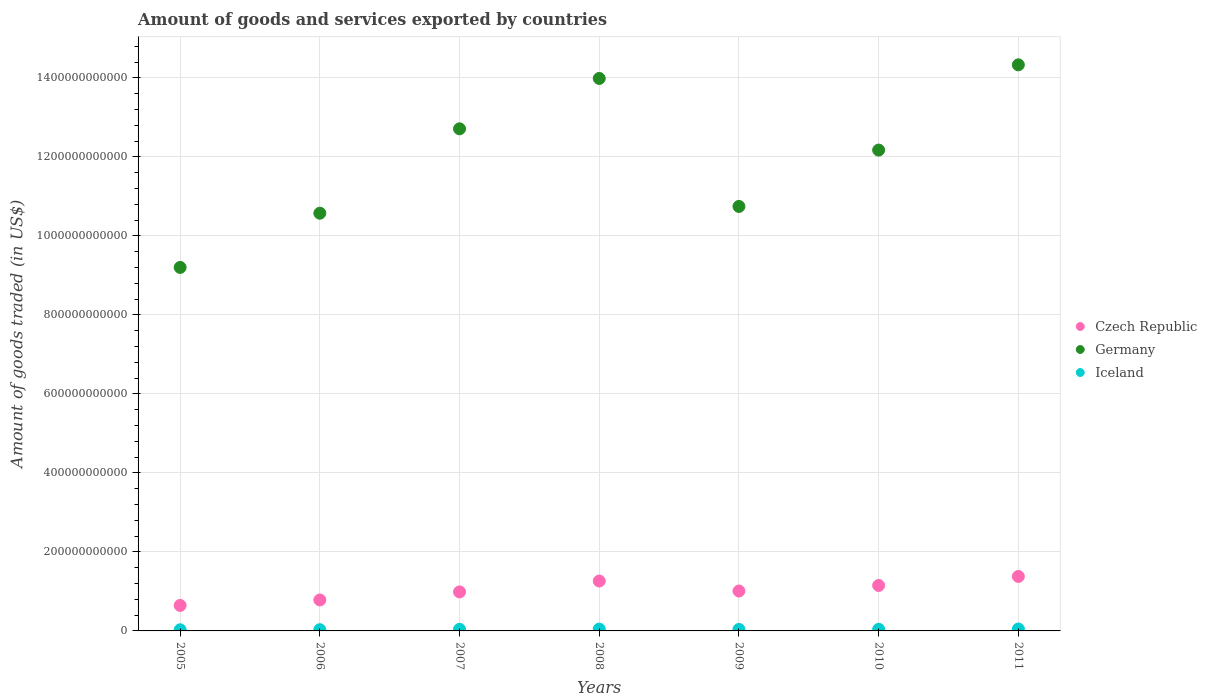What is the total amount of goods and services exported in Czech Republic in 2010?
Offer a terse response. 1.15e+11. Across all years, what is the maximum total amount of goods and services exported in Czech Republic?
Offer a very short reply. 1.38e+11. Across all years, what is the minimum total amount of goods and services exported in Germany?
Your answer should be compact. 9.20e+11. In which year was the total amount of goods and services exported in Germany maximum?
Your response must be concise. 2011. In which year was the total amount of goods and services exported in Iceland minimum?
Give a very brief answer. 2005. What is the total total amount of goods and services exported in Iceland in the graph?
Make the answer very short. 2.74e+1. What is the difference between the total amount of goods and services exported in Iceland in 2010 and that in 2011?
Offer a very short reply. -7.30e+08. What is the difference between the total amount of goods and services exported in Germany in 2006 and the total amount of goods and services exported in Czech Republic in 2008?
Your response must be concise. 9.31e+11. What is the average total amount of goods and services exported in Czech Republic per year?
Provide a short and direct response. 1.03e+11. In the year 2010, what is the difference between the total amount of goods and services exported in Germany and total amount of goods and services exported in Czech Republic?
Make the answer very short. 1.10e+12. In how many years, is the total amount of goods and services exported in Czech Republic greater than 360000000000 US$?
Your answer should be compact. 0. What is the ratio of the total amount of goods and services exported in Germany in 2006 to that in 2008?
Your response must be concise. 0.76. Is the difference between the total amount of goods and services exported in Germany in 2005 and 2008 greater than the difference between the total amount of goods and services exported in Czech Republic in 2005 and 2008?
Offer a terse response. No. What is the difference between the highest and the second highest total amount of goods and services exported in Iceland?
Offer a terse response. 1.99e+08. What is the difference between the highest and the lowest total amount of goods and services exported in Germany?
Provide a succinct answer. 5.13e+11. In how many years, is the total amount of goods and services exported in Czech Republic greater than the average total amount of goods and services exported in Czech Republic taken over all years?
Your answer should be very brief. 3. Is the sum of the total amount of goods and services exported in Germany in 2005 and 2009 greater than the maximum total amount of goods and services exported in Iceland across all years?
Make the answer very short. Yes. Does the total amount of goods and services exported in Czech Republic monotonically increase over the years?
Offer a very short reply. No. Is the total amount of goods and services exported in Germany strictly less than the total amount of goods and services exported in Iceland over the years?
Your answer should be very brief. No. How many dotlines are there?
Make the answer very short. 3. What is the difference between two consecutive major ticks on the Y-axis?
Provide a short and direct response. 2.00e+11. Are the values on the major ticks of Y-axis written in scientific E-notation?
Offer a terse response. No. How many legend labels are there?
Provide a succinct answer. 3. What is the title of the graph?
Give a very brief answer. Amount of goods and services exported by countries. Does "Portugal" appear as one of the legend labels in the graph?
Give a very brief answer. No. What is the label or title of the Y-axis?
Your response must be concise. Amount of goods traded (in US$). What is the Amount of goods traded (in US$) of Czech Republic in 2005?
Keep it short and to the point. 6.45e+1. What is the Amount of goods traded (in US$) in Germany in 2005?
Make the answer very short. 9.20e+11. What is the Amount of goods traded (in US$) of Iceland in 2005?
Make the answer very short. 2.89e+09. What is the Amount of goods traded (in US$) in Czech Republic in 2006?
Your answer should be very brief. 7.84e+1. What is the Amount of goods traded (in US$) in Germany in 2006?
Your answer should be compact. 1.06e+12. What is the Amount of goods traded (in US$) in Iceland in 2006?
Make the answer very short. 3.10e+09. What is the Amount of goods traded (in US$) in Czech Republic in 2007?
Ensure brevity in your answer.  9.88e+1. What is the Amount of goods traded (in US$) of Germany in 2007?
Give a very brief answer. 1.27e+12. What is the Amount of goods traded (in US$) of Iceland in 2007?
Your answer should be compact. 4.12e+09. What is the Amount of goods traded (in US$) in Czech Republic in 2008?
Provide a short and direct response. 1.26e+11. What is the Amount of goods traded (in US$) in Germany in 2008?
Provide a succinct answer. 1.40e+12. What is the Amount of goods traded (in US$) in Iceland in 2008?
Provide a succinct answer. 4.65e+09. What is the Amount of goods traded (in US$) in Czech Republic in 2009?
Your response must be concise. 1.01e+11. What is the Amount of goods traded (in US$) of Germany in 2009?
Keep it short and to the point. 1.07e+12. What is the Amount of goods traded (in US$) in Iceland in 2009?
Offer a terse response. 3.72e+09. What is the Amount of goods traded (in US$) of Czech Republic in 2010?
Provide a succinct answer. 1.15e+11. What is the Amount of goods traded (in US$) in Germany in 2010?
Your answer should be very brief. 1.22e+12. What is the Amount of goods traded (in US$) of Iceland in 2010?
Keep it short and to the point. 4.12e+09. What is the Amount of goods traded (in US$) of Czech Republic in 2011?
Offer a very short reply. 1.38e+11. What is the Amount of goods traded (in US$) of Germany in 2011?
Your answer should be very brief. 1.43e+12. What is the Amount of goods traded (in US$) in Iceland in 2011?
Provide a short and direct response. 4.85e+09. Across all years, what is the maximum Amount of goods traded (in US$) in Czech Republic?
Offer a very short reply. 1.38e+11. Across all years, what is the maximum Amount of goods traded (in US$) in Germany?
Ensure brevity in your answer.  1.43e+12. Across all years, what is the maximum Amount of goods traded (in US$) in Iceland?
Give a very brief answer. 4.85e+09. Across all years, what is the minimum Amount of goods traded (in US$) in Czech Republic?
Ensure brevity in your answer.  6.45e+1. Across all years, what is the minimum Amount of goods traded (in US$) in Germany?
Keep it short and to the point. 9.20e+11. Across all years, what is the minimum Amount of goods traded (in US$) of Iceland?
Your answer should be compact. 2.89e+09. What is the total Amount of goods traded (in US$) of Czech Republic in the graph?
Offer a terse response. 7.22e+11. What is the total Amount of goods traded (in US$) of Germany in the graph?
Your answer should be compact. 8.37e+12. What is the total Amount of goods traded (in US$) in Iceland in the graph?
Ensure brevity in your answer.  2.74e+1. What is the difference between the Amount of goods traded (in US$) in Czech Republic in 2005 and that in 2006?
Give a very brief answer. -1.38e+1. What is the difference between the Amount of goods traded (in US$) in Germany in 2005 and that in 2006?
Your answer should be very brief. -1.37e+11. What is the difference between the Amount of goods traded (in US$) of Iceland in 2005 and that in 2006?
Keep it short and to the point. -2.13e+08. What is the difference between the Amount of goods traded (in US$) in Czech Republic in 2005 and that in 2007?
Your response must be concise. -3.43e+1. What is the difference between the Amount of goods traded (in US$) in Germany in 2005 and that in 2007?
Offer a very short reply. -3.51e+11. What is the difference between the Amount of goods traded (in US$) of Iceland in 2005 and that in 2007?
Provide a succinct answer. -1.23e+09. What is the difference between the Amount of goods traded (in US$) of Czech Republic in 2005 and that in 2008?
Ensure brevity in your answer.  -6.18e+1. What is the difference between the Amount of goods traded (in US$) in Germany in 2005 and that in 2008?
Make the answer very short. -4.78e+11. What is the difference between the Amount of goods traded (in US$) of Iceland in 2005 and that in 2008?
Offer a very short reply. -1.77e+09. What is the difference between the Amount of goods traded (in US$) in Czech Republic in 2005 and that in 2009?
Make the answer very short. -3.65e+1. What is the difference between the Amount of goods traded (in US$) in Germany in 2005 and that in 2009?
Offer a very short reply. -1.54e+11. What is the difference between the Amount of goods traded (in US$) of Iceland in 2005 and that in 2009?
Keep it short and to the point. -8.30e+08. What is the difference between the Amount of goods traded (in US$) of Czech Republic in 2005 and that in 2010?
Offer a terse response. -5.05e+1. What is the difference between the Amount of goods traded (in US$) of Germany in 2005 and that in 2010?
Provide a succinct answer. -2.97e+11. What is the difference between the Amount of goods traded (in US$) in Iceland in 2005 and that in 2010?
Offer a very short reply. -1.24e+09. What is the difference between the Amount of goods traded (in US$) in Czech Republic in 2005 and that in 2011?
Keep it short and to the point. -7.34e+1. What is the difference between the Amount of goods traded (in US$) in Germany in 2005 and that in 2011?
Your answer should be very brief. -5.13e+11. What is the difference between the Amount of goods traded (in US$) of Iceland in 2005 and that in 2011?
Give a very brief answer. -1.97e+09. What is the difference between the Amount of goods traded (in US$) in Czech Republic in 2006 and that in 2007?
Give a very brief answer. -2.04e+1. What is the difference between the Amount of goods traded (in US$) of Germany in 2006 and that in 2007?
Offer a very short reply. -2.14e+11. What is the difference between the Amount of goods traded (in US$) of Iceland in 2006 and that in 2007?
Make the answer very short. -1.02e+09. What is the difference between the Amount of goods traded (in US$) of Czech Republic in 2006 and that in 2008?
Make the answer very short. -4.80e+1. What is the difference between the Amount of goods traded (in US$) of Germany in 2006 and that in 2008?
Your answer should be very brief. -3.41e+11. What is the difference between the Amount of goods traded (in US$) in Iceland in 2006 and that in 2008?
Ensure brevity in your answer.  -1.55e+09. What is the difference between the Amount of goods traded (in US$) in Czech Republic in 2006 and that in 2009?
Keep it short and to the point. -2.26e+1. What is the difference between the Amount of goods traded (in US$) of Germany in 2006 and that in 2009?
Provide a short and direct response. -1.71e+1. What is the difference between the Amount of goods traded (in US$) of Iceland in 2006 and that in 2009?
Keep it short and to the point. -6.17e+08. What is the difference between the Amount of goods traded (in US$) of Czech Republic in 2006 and that in 2010?
Ensure brevity in your answer.  -3.67e+1. What is the difference between the Amount of goods traded (in US$) in Germany in 2006 and that in 2010?
Ensure brevity in your answer.  -1.60e+11. What is the difference between the Amount of goods traded (in US$) in Iceland in 2006 and that in 2010?
Your answer should be very brief. -1.02e+09. What is the difference between the Amount of goods traded (in US$) of Czech Republic in 2006 and that in 2011?
Offer a very short reply. -5.95e+1. What is the difference between the Amount of goods traded (in US$) of Germany in 2006 and that in 2011?
Offer a very short reply. -3.76e+11. What is the difference between the Amount of goods traded (in US$) in Iceland in 2006 and that in 2011?
Ensure brevity in your answer.  -1.75e+09. What is the difference between the Amount of goods traded (in US$) in Czech Republic in 2007 and that in 2008?
Your answer should be very brief. -2.76e+1. What is the difference between the Amount of goods traded (in US$) in Germany in 2007 and that in 2008?
Offer a terse response. -1.27e+11. What is the difference between the Amount of goods traded (in US$) of Iceland in 2007 and that in 2008?
Ensure brevity in your answer.  -5.34e+08. What is the difference between the Amount of goods traded (in US$) in Czech Republic in 2007 and that in 2009?
Ensure brevity in your answer.  -2.24e+09. What is the difference between the Amount of goods traded (in US$) in Germany in 2007 and that in 2009?
Keep it short and to the point. 1.96e+11. What is the difference between the Amount of goods traded (in US$) of Iceland in 2007 and that in 2009?
Your answer should be very brief. 4.02e+08. What is the difference between the Amount of goods traded (in US$) in Czech Republic in 2007 and that in 2010?
Ensure brevity in your answer.  -1.63e+1. What is the difference between the Amount of goods traded (in US$) of Germany in 2007 and that in 2010?
Make the answer very short. 5.38e+1. What is the difference between the Amount of goods traded (in US$) in Iceland in 2007 and that in 2010?
Your response must be concise. -3.23e+06. What is the difference between the Amount of goods traded (in US$) of Czech Republic in 2007 and that in 2011?
Keep it short and to the point. -3.91e+1. What is the difference between the Amount of goods traded (in US$) in Germany in 2007 and that in 2011?
Your answer should be compact. -1.62e+11. What is the difference between the Amount of goods traded (in US$) of Iceland in 2007 and that in 2011?
Make the answer very short. -7.33e+08. What is the difference between the Amount of goods traded (in US$) of Czech Republic in 2008 and that in 2009?
Make the answer very short. 2.53e+1. What is the difference between the Amount of goods traded (in US$) in Germany in 2008 and that in 2009?
Your answer should be very brief. 3.24e+11. What is the difference between the Amount of goods traded (in US$) of Iceland in 2008 and that in 2009?
Make the answer very short. 9.37e+08. What is the difference between the Amount of goods traded (in US$) of Czech Republic in 2008 and that in 2010?
Provide a succinct answer. 1.13e+1. What is the difference between the Amount of goods traded (in US$) in Germany in 2008 and that in 2010?
Your response must be concise. 1.81e+11. What is the difference between the Amount of goods traded (in US$) of Iceland in 2008 and that in 2010?
Make the answer very short. 5.31e+08. What is the difference between the Amount of goods traded (in US$) of Czech Republic in 2008 and that in 2011?
Give a very brief answer. -1.15e+1. What is the difference between the Amount of goods traded (in US$) of Germany in 2008 and that in 2011?
Offer a very short reply. -3.45e+1. What is the difference between the Amount of goods traded (in US$) of Iceland in 2008 and that in 2011?
Provide a short and direct response. -1.99e+08. What is the difference between the Amount of goods traded (in US$) in Czech Republic in 2009 and that in 2010?
Offer a very short reply. -1.40e+1. What is the difference between the Amount of goods traded (in US$) in Germany in 2009 and that in 2010?
Provide a short and direct response. -1.43e+11. What is the difference between the Amount of goods traded (in US$) of Iceland in 2009 and that in 2010?
Keep it short and to the point. -4.06e+08. What is the difference between the Amount of goods traded (in US$) of Czech Republic in 2009 and that in 2011?
Make the answer very short. -3.69e+1. What is the difference between the Amount of goods traded (in US$) in Germany in 2009 and that in 2011?
Your response must be concise. -3.58e+11. What is the difference between the Amount of goods traded (in US$) in Iceland in 2009 and that in 2011?
Your answer should be compact. -1.14e+09. What is the difference between the Amount of goods traded (in US$) of Czech Republic in 2010 and that in 2011?
Give a very brief answer. -2.28e+1. What is the difference between the Amount of goods traded (in US$) of Germany in 2010 and that in 2011?
Provide a succinct answer. -2.16e+11. What is the difference between the Amount of goods traded (in US$) in Iceland in 2010 and that in 2011?
Your answer should be compact. -7.30e+08. What is the difference between the Amount of goods traded (in US$) in Czech Republic in 2005 and the Amount of goods traded (in US$) in Germany in 2006?
Give a very brief answer. -9.93e+11. What is the difference between the Amount of goods traded (in US$) of Czech Republic in 2005 and the Amount of goods traded (in US$) of Iceland in 2006?
Give a very brief answer. 6.14e+1. What is the difference between the Amount of goods traded (in US$) of Germany in 2005 and the Amount of goods traded (in US$) of Iceland in 2006?
Offer a very short reply. 9.17e+11. What is the difference between the Amount of goods traded (in US$) of Czech Republic in 2005 and the Amount of goods traded (in US$) of Germany in 2007?
Make the answer very short. -1.21e+12. What is the difference between the Amount of goods traded (in US$) in Czech Republic in 2005 and the Amount of goods traded (in US$) in Iceland in 2007?
Your answer should be compact. 6.04e+1. What is the difference between the Amount of goods traded (in US$) of Germany in 2005 and the Amount of goods traded (in US$) of Iceland in 2007?
Ensure brevity in your answer.  9.16e+11. What is the difference between the Amount of goods traded (in US$) in Czech Republic in 2005 and the Amount of goods traded (in US$) in Germany in 2008?
Your answer should be very brief. -1.33e+12. What is the difference between the Amount of goods traded (in US$) in Czech Republic in 2005 and the Amount of goods traded (in US$) in Iceland in 2008?
Your answer should be very brief. 5.99e+1. What is the difference between the Amount of goods traded (in US$) of Germany in 2005 and the Amount of goods traded (in US$) of Iceland in 2008?
Your answer should be very brief. 9.15e+11. What is the difference between the Amount of goods traded (in US$) of Czech Republic in 2005 and the Amount of goods traded (in US$) of Germany in 2009?
Your response must be concise. -1.01e+12. What is the difference between the Amount of goods traded (in US$) in Czech Republic in 2005 and the Amount of goods traded (in US$) in Iceland in 2009?
Ensure brevity in your answer.  6.08e+1. What is the difference between the Amount of goods traded (in US$) of Germany in 2005 and the Amount of goods traded (in US$) of Iceland in 2009?
Give a very brief answer. 9.16e+11. What is the difference between the Amount of goods traded (in US$) in Czech Republic in 2005 and the Amount of goods traded (in US$) in Germany in 2010?
Offer a terse response. -1.15e+12. What is the difference between the Amount of goods traded (in US$) in Czech Republic in 2005 and the Amount of goods traded (in US$) in Iceland in 2010?
Offer a terse response. 6.04e+1. What is the difference between the Amount of goods traded (in US$) in Germany in 2005 and the Amount of goods traded (in US$) in Iceland in 2010?
Offer a terse response. 9.16e+11. What is the difference between the Amount of goods traded (in US$) of Czech Republic in 2005 and the Amount of goods traded (in US$) of Germany in 2011?
Make the answer very short. -1.37e+12. What is the difference between the Amount of goods traded (in US$) of Czech Republic in 2005 and the Amount of goods traded (in US$) of Iceland in 2011?
Offer a very short reply. 5.97e+1. What is the difference between the Amount of goods traded (in US$) in Germany in 2005 and the Amount of goods traded (in US$) in Iceland in 2011?
Make the answer very short. 9.15e+11. What is the difference between the Amount of goods traded (in US$) in Czech Republic in 2006 and the Amount of goods traded (in US$) in Germany in 2007?
Ensure brevity in your answer.  -1.19e+12. What is the difference between the Amount of goods traded (in US$) of Czech Republic in 2006 and the Amount of goods traded (in US$) of Iceland in 2007?
Offer a very short reply. 7.43e+1. What is the difference between the Amount of goods traded (in US$) in Germany in 2006 and the Amount of goods traded (in US$) in Iceland in 2007?
Offer a terse response. 1.05e+12. What is the difference between the Amount of goods traded (in US$) in Czech Republic in 2006 and the Amount of goods traded (in US$) in Germany in 2008?
Give a very brief answer. -1.32e+12. What is the difference between the Amount of goods traded (in US$) of Czech Republic in 2006 and the Amount of goods traded (in US$) of Iceland in 2008?
Make the answer very short. 7.37e+1. What is the difference between the Amount of goods traded (in US$) in Germany in 2006 and the Amount of goods traded (in US$) in Iceland in 2008?
Offer a very short reply. 1.05e+12. What is the difference between the Amount of goods traded (in US$) in Czech Republic in 2006 and the Amount of goods traded (in US$) in Germany in 2009?
Provide a succinct answer. -9.96e+11. What is the difference between the Amount of goods traded (in US$) in Czech Republic in 2006 and the Amount of goods traded (in US$) in Iceland in 2009?
Ensure brevity in your answer.  7.47e+1. What is the difference between the Amount of goods traded (in US$) of Germany in 2006 and the Amount of goods traded (in US$) of Iceland in 2009?
Ensure brevity in your answer.  1.05e+12. What is the difference between the Amount of goods traded (in US$) in Czech Republic in 2006 and the Amount of goods traded (in US$) in Germany in 2010?
Your answer should be very brief. -1.14e+12. What is the difference between the Amount of goods traded (in US$) of Czech Republic in 2006 and the Amount of goods traded (in US$) of Iceland in 2010?
Your response must be concise. 7.43e+1. What is the difference between the Amount of goods traded (in US$) of Germany in 2006 and the Amount of goods traded (in US$) of Iceland in 2010?
Offer a very short reply. 1.05e+12. What is the difference between the Amount of goods traded (in US$) of Czech Republic in 2006 and the Amount of goods traded (in US$) of Germany in 2011?
Offer a very short reply. -1.35e+12. What is the difference between the Amount of goods traded (in US$) of Czech Republic in 2006 and the Amount of goods traded (in US$) of Iceland in 2011?
Give a very brief answer. 7.35e+1. What is the difference between the Amount of goods traded (in US$) in Germany in 2006 and the Amount of goods traded (in US$) in Iceland in 2011?
Keep it short and to the point. 1.05e+12. What is the difference between the Amount of goods traded (in US$) of Czech Republic in 2007 and the Amount of goods traded (in US$) of Germany in 2008?
Make the answer very short. -1.30e+12. What is the difference between the Amount of goods traded (in US$) of Czech Republic in 2007 and the Amount of goods traded (in US$) of Iceland in 2008?
Your response must be concise. 9.41e+1. What is the difference between the Amount of goods traded (in US$) of Germany in 2007 and the Amount of goods traded (in US$) of Iceland in 2008?
Offer a terse response. 1.27e+12. What is the difference between the Amount of goods traded (in US$) in Czech Republic in 2007 and the Amount of goods traded (in US$) in Germany in 2009?
Offer a terse response. -9.76e+11. What is the difference between the Amount of goods traded (in US$) of Czech Republic in 2007 and the Amount of goods traded (in US$) of Iceland in 2009?
Your answer should be very brief. 9.51e+1. What is the difference between the Amount of goods traded (in US$) of Germany in 2007 and the Amount of goods traded (in US$) of Iceland in 2009?
Your response must be concise. 1.27e+12. What is the difference between the Amount of goods traded (in US$) in Czech Republic in 2007 and the Amount of goods traded (in US$) in Germany in 2010?
Your answer should be very brief. -1.12e+12. What is the difference between the Amount of goods traded (in US$) of Czech Republic in 2007 and the Amount of goods traded (in US$) of Iceland in 2010?
Make the answer very short. 9.47e+1. What is the difference between the Amount of goods traded (in US$) in Germany in 2007 and the Amount of goods traded (in US$) in Iceland in 2010?
Your answer should be very brief. 1.27e+12. What is the difference between the Amount of goods traded (in US$) in Czech Republic in 2007 and the Amount of goods traded (in US$) in Germany in 2011?
Keep it short and to the point. -1.33e+12. What is the difference between the Amount of goods traded (in US$) of Czech Republic in 2007 and the Amount of goods traded (in US$) of Iceland in 2011?
Provide a succinct answer. 9.39e+1. What is the difference between the Amount of goods traded (in US$) of Germany in 2007 and the Amount of goods traded (in US$) of Iceland in 2011?
Your answer should be very brief. 1.27e+12. What is the difference between the Amount of goods traded (in US$) in Czech Republic in 2008 and the Amount of goods traded (in US$) in Germany in 2009?
Offer a very short reply. -9.48e+11. What is the difference between the Amount of goods traded (in US$) in Czech Republic in 2008 and the Amount of goods traded (in US$) in Iceland in 2009?
Keep it short and to the point. 1.23e+11. What is the difference between the Amount of goods traded (in US$) of Germany in 2008 and the Amount of goods traded (in US$) of Iceland in 2009?
Keep it short and to the point. 1.39e+12. What is the difference between the Amount of goods traded (in US$) in Czech Republic in 2008 and the Amount of goods traded (in US$) in Germany in 2010?
Your answer should be very brief. -1.09e+12. What is the difference between the Amount of goods traded (in US$) in Czech Republic in 2008 and the Amount of goods traded (in US$) in Iceland in 2010?
Keep it short and to the point. 1.22e+11. What is the difference between the Amount of goods traded (in US$) of Germany in 2008 and the Amount of goods traded (in US$) of Iceland in 2010?
Your response must be concise. 1.39e+12. What is the difference between the Amount of goods traded (in US$) of Czech Republic in 2008 and the Amount of goods traded (in US$) of Germany in 2011?
Offer a very short reply. -1.31e+12. What is the difference between the Amount of goods traded (in US$) of Czech Republic in 2008 and the Amount of goods traded (in US$) of Iceland in 2011?
Offer a very short reply. 1.21e+11. What is the difference between the Amount of goods traded (in US$) in Germany in 2008 and the Amount of goods traded (in US$) in Iceland in 2011?
Your response must be concise. 1.39e+12. What is the difference between the Amount of goods traded (in US$) in Czech Republic in 2009 and the Amount of goods traded (in US$) in Germany in 2010?
Your response must be concise. -1.12e+12. What is the difference between the Amount of goods traded (in US$) in Czech Republic in 2009 and the Amount of goods traded (in US$) in Iceland in 2010?
Ensure brevity in your answer.  9.69e+1. What is the difference between the Amount of goods traded (in US$) in Germany in 2009 and the Amount of goods traded (in US$) in Iceland in 2010?
Your answer should be compact. 1.07e+12. What is the difference between the Amount of goods traded (in US$) of Czech Republic in 2009 and the Amount of goods traded (in US$) of Germany in 2011?
Offer a terse response. -1.33e+12. What is the difference between the Amount of goods traded (in US$) in Czech Republic in 2009 and the Amount of goods traded (in US$) in Iceland in 2011?
Ensure brevity in your answer.  9.62e+1. What is the difference between the Amount of goods traded (in US$) of Germany in 2009 and the Amount of goods traded (in US$) of Iceland in 2011?
Provide a short and direct response. 1.07e+12. What is the difference between the Amount of goods traded (in US$) in Czech Republic in 2010 and the Amount of goods traded (in US$) in Germany in 2011?
Give a very brief answer. -1.32e+12. What is the difference between the Amount of goods traded (in US$) in Czech Republic in 2010 and the Amount of goods traded (in US$) in Iceland in 2011?
Give a very brief answer. 1.10e+11. What is the difference between the Amount of goods traded (in US$) of Germany in 2010 and the Amount of goods traded (in US$) of Iceland in 2011?
Ensure brevity in your answer.  1.21e+12. What is the average Amount of goods traded (in US$) in Czech Republic per year?
Your answer should be very brief. 1.03e+11. What is the average Amount of goods traded (in US$) of Germany per year?
Make the answer very short. 1.20e+12. What is the average Amount of goods traded (in US$) in Iceland per year?
Offer a terse response. 3.92e+09. In the year 2005, what is the difference between the Amount of goods traded (in US$) in Czech Republic and Amount of goods traded (in US$) in Germany?
Give a very brief answer. -8.56e+11. In the year 2005, what is the difference between the Amount of goods traded (in US$) of Czech Republic and Amount of goods traded (in US$) of Iceland?
Your answer should be very brief. 6.16e+1. In the year 2005, what is the difference between the Amount of goods traded (in US$) in Germany and Amount of goods traded (in US$) in Iceland?
Your response must be concise. 9.17e+11. In the year 2006, what is the difference between the Amount of goods traded (in US$) in Czech Republic and Amount of goods traded (in US$) in Germany?
Keep it short and to the point. -9.79e+11. In the year 2006, what is the difference between the Amount of goods traded (in US$) in Czech Republic and Amount of goods traded (in US$) in Iceland?
Make the answer very short. 7.53e+1. In the year 2006, what is the difference between the Amount of goods traded (in US$) in Germany and Amount of goods traded (in US$) in Iceland?
Offer a very short reply. 1.05e+12. In the year 2007, what is the difference between the Amount of goods traded (in US$) in Czech Republic and Amount of goods traded (in US$) in Germany?
Provide a succinct answer. -1.17e+12. In the year 2007, what is the difference between the Amount of goods traded (in US$) of Czech Republic and Amount of goods traded (in US$) of Iceland?
Offer a very short reply. 9.47e+1. In the year 2007, what is the difference between the Amount of goods traded (in US$) in Germany and Amount of goods traded (in US$) in Iceland?
Your answer should be very brief. 1.27e+12. In the year 2008, what is the difference between the Amount of goods traded (in US$) in Czech Republic and Amount of goods traded (in US$) in Germany?
Your answer should be very brief. -1.27e+12. In the year 2008, what is the difference between the Amount of goods traded (in US$) in Czech Republic and Amount of goods traded (in US$) in Iceland?
Your answer should be very brief. 1.22e+11. In the year 2008, what is the difference between the Amount of goods traded (in US$) in Germany and Amount of goods traded (in US$) in Iceland?
Give a very brief answer. 1.39e+12. In the year 2009, what is the difference between the Amount of goods traded (in US$) in Czech Republic and Amount of goods traded (in US$) in Germany?
Provide a succinct answer. -9.73e+11. In the year 2009, what is the difference between the Amount of goods traded (in US$) of Czech Republic and Amount of goods traded (in US$) of Iceland?
Keep it short and to the point. 9.73e+1. In the year 2009, what is the difference between the Amount of goods traded (in US$) of Germany and Amount of goods traded (in US$) of Iceland?
Provide a short and direct response. 1.07e+12. In the year 2010, what is the difference between the Amount of goods traded (in US$) in Czech Republic and Amount of goods traded (in US$) in Germany?
Provide a short and direct response. -1.10e+12. In the year 2010, what is the difference between the Amount of goods traded (in US$) of Czech Republic and Amount of goods traded (in US$) of Iceland?
Make the answer very short. 1.11e+11. In the year 2010, what is the difference between the Amount of goods traded (in US$) in Germany and Amount of goods traded (in US$) in Iceland?
Give a very brief answer. 1.21e+12. In the year 2011, what is the difference between the Amount of goods traded (in US$) of Czech Republic and Amount of goods traded (in US$) of Germany?
Keep it short and to the point. -1.30e+12. In the year 2011, what is the difference between the Amount of goods traded (in US$) in Czech Republic and Amount of goods traded (in US$) in Iceland?
Your response must be concise. 1.33e+11. In the year 2011, what is the difference between the Amount of goods traded (in US$) of Germany and Amount of goods traded (in US$) of Iceland?
Give a very brief answer. 1.43e+12. What is the ratio of the Amount of goods traded (in US$) of Czech Republic in 2005 to that in 2006?
Offer a terse response. 0.82. What is the ratio of the Amount of goods traded (in US$) of Germany in 2005 to that in 2006?
Offer a very short reply. 0.87. What is the ratio of the Amount of goods traded (in US$) in Iceland in 2005 to that in 2006?
Your response must be concise. 0.93. What is the ratio of the Amount of goods traded (in US$) of Czech Republic in 2005 to that in 2007?
Offer a very short reply. 0.65. What is the ratio of the Amount of goods traded (in US$) of Germany in 2005 to that in 2007?
Your response must be concise. 0.72. What is the ratio of the Amount of goods traded (in US$) in Iceland in 2005 to that in 2007?
Make the answer very short. 0.7. What is the ratio of the Amount of goods traded (in US$) of Czech Republic in 2005 to that in 2008?
Offer a terse response. 0.51. What is the ratio of the Amount of goods traded (in US$) in Germany in 2005 to that in 2008?
Provide a succinct answer. 0.66. What is the ratio of the Amount of goods traded (in US$) in Iceland in 2005 to that in 2008?
Your answer should be compact. 0.62. What is the ratio of the Amount of goods traded (in US$) in Czech Republic in 2005 to that in 2009?
Offer a terse response. 0.64. What is the ratio of the Amount of goods traded (in US$) of Germany in 2005 to that in 2009?
Provide a succinct answer. 0.86. What is the ratio of the Amount of goods traded (in US$) in Iceland in 2005 to that in 2009?
Provide a short and direct response. 0.78. What is the ratio of the Amount of goods traded (in US$) in Czech Republic in 2005 to that in 2010?
Your answer should be very brief. 0.56. What is the ratio of the Amount of goods traded (in US$) of Germany in 2005 to that in 2010?
Your response must be concise. 0.76. What is the ratio of the Amount of goods traded (in US$) of Iceland in 2005 to that in 2010?
Your response must be concise. 0.7. What is the ratio of the Amount of goods traded (in US$) in Czech Republic in 2005 to that in 2011?
Make the answer very short. 0.47. What is the ratio of the Amount of goods traded (in US$) in Germany in 2005 to that in 2011?
Make the answer very short. 0.64. What is the ratio of the Amount of goods traded (in US$) of Iceland in 2005 to that in 2011?
Your answer should be compact. 0.59. What is the ratio of the Amount of goods traded (in US$) of Czech Republic in 2006 to that in 2007?
Keep it short and to the point. 0.79. What is the ratio of the Amount of goods traded (in US$) in Germany in 2006 to that in 2007?
Provide a short and direct response. 0.83. What is the ratio of the Amount of goods traded (in US$) in Iceland in 2006 to that in 2007?
Give a very brief answer. 0.75. What is the ratio of the Amount of goods traded (in US$) in Czech Republic in 2006 to that in 2008?
Your response must be concise. 0.62. What is the ratio of the Amount of goods traded (in US$) in Germany in 2006 to that in 2008?
Your answer should be very brief. 0.76. What is the ratio of the Amount of goods traded (in US$) in Iceland in 2006 to that in 2008?
Give a very brief answer. 0.67. What is the ratio of the Amount of goods traded (in US$) in Czech Republic in 2006 to that in 2009?
Your answer should be compact. 0.78. What is the ratio of the Amount of goods traded (in US$) of Germany in 2006 to that in 2009?
Your answer should be compact. 0.98. What is the ratio of the Amount of goods traded (in US$) of Iceland in 2006 to that in 2009?
Your response must be concise. 0.83. What is the ratio of the Amount of goods traded (in US$) of Czech Republic in 2006 to that in 2010?
Make the answer very short. 0.68. What is the ratio of the Amount of goods traded (in US$) of Germany in 2006 to that in 2010?
Ensure brevity in your answer.  0.87. What is the ratio of the Amount of goods traded (in US$) in Iceland in 2006 to that in 2010?
Provide a short and direct response. 0.75. What is the ratio of the Amount of goods traded (in US$) of Czech Republic in 2006 to that in 2011?
Give a very brief answer. 0.57. What is the ratio of the Amount of goods traded (in US$) of Germany in 2006 to that in 2011?
Ensure brevity in your answer.  0.74. What is the ratio of the Amount of goods traded (in US$) of Iceland in 2006 to that in 2011?
Provide a succinct answer. 0.64. What is the ratio of the Amount of goods traded (in US$) of Czech Republic in 2007 to that in 2008?
Keep it short and to the point. 0.78. What is the ratio of the Amount of goods traded (in US$) of Germany in 2007 to that in 2008?
Provide a short and direct response. 0.91. What is the ratio of the Amount of goods traded (in US$) of Iceland in 2007 to that in 2008?
Ensure brevity in your answer.  0.89. What is the ratio of the Amount of goods traded (in US$) of Czech Republic in 2007 to that in 2009?
Make the answer very short. 0.98. What is the ratio of the Amount of goods traded (in US$) in Germany in 2007 to that in 2009?
Make the answer very short. 1.18. What is the ratio of the Amount of goods traded (in US$) of Iceland in 2007 to that in 2009?
Your response must be concise. 1.11. What is the ratio of the Amount of goods traded (in US$) in Czech Republic in 2007 to that in 2010?
Provide a short and direct response. 0.86. What is the ratio of the Amount of goods traded (in US$) in Germany in 2007 to that in 2010?
Give a very brief answer. 1.04. What is the ratio of the Amount of goods traded (in US$) of Czech Republic in 2007 to that in 2011?
Offer a very short reply. 0.72. What is the ratio of the Amount of goods traded (in US$) in Germany in 2007 to that in 2011?
Ensure brevity in your answer.  0.89. What is the ratio of the Amount of goods traded (in US$) in Iceland in 2007 to that in 2011?
Provide a succinct answer. 0.85. What is the ratio of the Amount of goods traded (in US$) of Czech Republic in 2008 to that in 2009?
Keep it short and to the point. 1.25. What is the ratio of the Amount of goods traded (in US$) in Germany in 2008 to that in 2009?
Give a very brief answer. 1.3. What is the ratio of the Amount of goods traded (in US$) of Iceland in 2008 to that in 2009?
Ensure brevity in your answer.  1.25. What is the ratio of the Amount of goods traded (in US$) in Czech Republic in 2008 to that in 2010?
Ensure brevity in your answer.  1.1. What is the ratio of the Amount of goods traded (in US$) of Germany in 2008 to that in 2010?
Make the answer very short. 1.15. What is the ratio of the Amount of goods traded (in US$) of Iceland in 2008 to that in 2010?
Your response must be concise. 1.13. What is the ratio of the Amount of goods traded (in US$) of Czech Republic in 2008 to that in 2011?
Offer a terse response. 0.92. What is the ratio of the Amount of goods traded (in US$) in Germany in 2008 to that in 2011?
Provide a short and direct response. 0.98. What is the ratio of the Amount of goods traded (in US$) of Iceland in 2008 to that in 2011?
Provide a succinct answer. 0.96. What is the ratio of the Amount of goods traded (in US$) of Czech Republic in 2009 to that in 2010?
Provide a succinct answer. 0.88. What is the ratio of the Amount of goods traded (in US$) in Germany in 2009 to that in 2010?
Your response must be concise. 0.88. What is the ratio of the Amount of goods traded (in US$) of Iceland in 2009 to that in 2010?
Your response must be concise. 0.9. What is the ratio of the Amount of goods traded (in US$) in Czech Republic in 2009 to that in 2011?
Your answer should be very brief. 0.73. What is the ratio of the Amount of goods traded (in US$) of Germany in 2009 to that in 2011?
Provide a succinct answer. 0.75. What is the ratio of the Amount of goods traded (in US$) in Iceland in 2009 to that in 2011?
Provide a short and direct response. 0.77. What is the ratio of the Amount of goods traded (in US$) of Czech Republic in 2010 to that in 2011?
Your response must be concise. 0.83. What is the ratio of the Amount of goods traded (in US$) in Germany in 2010 to that in 2011?
Make the answer very short. 0.85. What is the ratio of the Amount of goods traded (in US$) in Iceland in 2010 to that in 2011?
Provide a short and direct response. 0.85. What is the difference between the highest and the second highest Amount of goods traded (in US$) in Czech Republic?
Offer a terse response. 1.15e+1. What is the difference between the highest and the second highest Amount of goods traded (in US$) of Germany?
Your answer should be compact. 3.45e+1. What is the difference between the highest and the second highest Amount of goods traded (in US$) in Iceland?
Give a very brief answer. 1.99e+08. What is the difference between the highest and the lowest Amount of goods traded (in US$) in Czech Republic?
Ensure brevity in your answer.  7.34e+1. What is the difference between the highest and the lowest Amount of goods traded (in US$) in Germany?
Offer a terse response. 5.13e+11. What is the difference between the highest and the lowest Amount of goods traded (in US$) of Iceland?
Make the answer very short. 1.97e+09. 